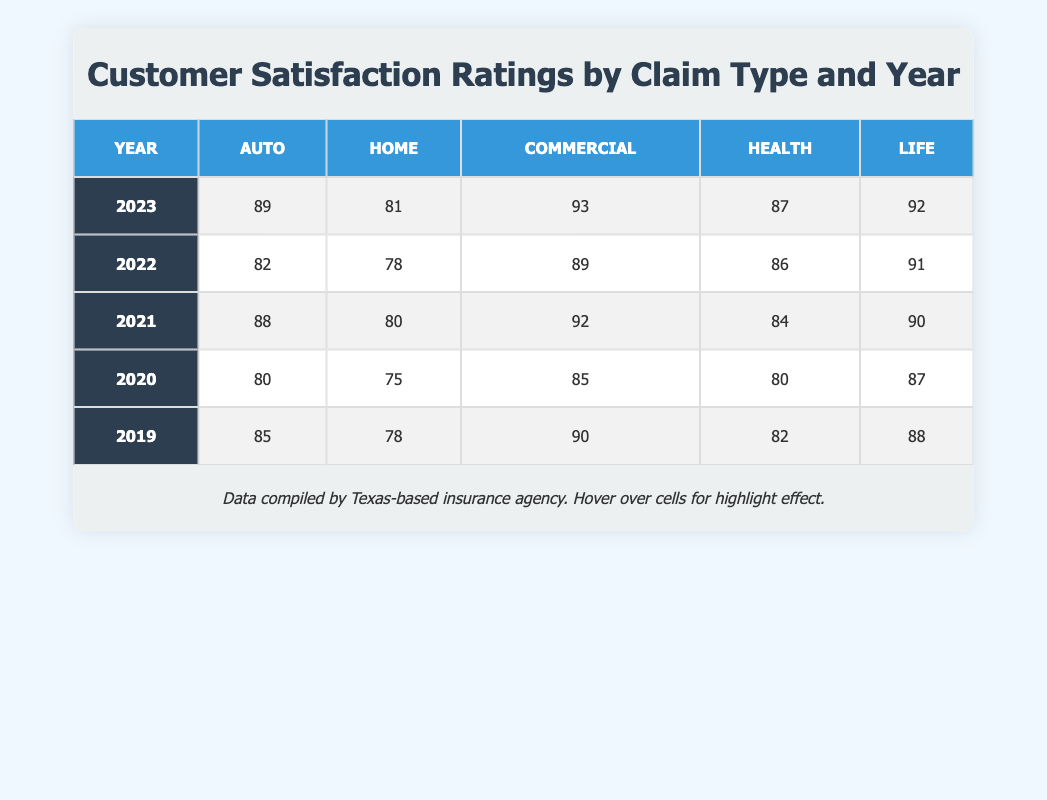What was the customer satisfaction rating for Commercial claims in 2021? The table shows that the rating for Commercial claims in 2021 is indicated in the specific cell corresponding to that year and claim type, which is 92.
Answer: 92 Which claim type had the lowest customer satisfaction rating in 2020? In the year 2020, the ratings for each claim type are as follows: Auto 80, Home 75, Commercial 85, Health 80, Life 87. The Home claim type has the lowest rating at 75.
Answer: Home What is the average customer satisfaction rating for Health claims over the provided years? To find the average for Health claims, we use the ratings from all years: (82 + 80 + 84 + 86 + 87) / 5 = 419 / 5 = 83.8.
Answer: 83.8 Did the customer satisfaction rating for Auto claims improve from 2020 to 2021? The rating for Auto claims in 2020 is 80, while in 2021 it is 88. Since 88 is greater than 80, this indicates that there was an improvement.
Answer: Yes Which year saw the highest customer satisfaction rating for Life claims? By checking the ratings for Life claims across the years, we see they are: 88 (2019), 87 (2020), 90 (2021), 91 (2022), and 92 (2023). The highest rating of 92 occurred in 2023.
Answer: 2023 What is the difference in customer satisfaction ratings for Home claims between 2019 and 2023? The rating for Home claims in 2019 is 78 and in 2023 it is 81. To find the difference, we subtract 78 from 81, resulting in 3.
Answer: 3 Which claim type consistently had the highest ratings across all years listed? By examining the ratings in the table, we see the ratings for each claim type: Commercial has values of 90, 85, 92, 89, and 93, while no other type exceeds these values in any year consistently. Commercial claims had the highest overall ratings.
Answer: Commercial Is it true that all claim types had a higher satisfaction rating in 2023 compared to 2022? The ratings for 2022 and 2023 are compared for each type: Auto (82 vs 89), Home (78 vs 81), Commercial (89 vs 93), Health (86 vs 87), and Life (91 vs 92). Since all comparisons show that 2023 ratings are higher, it is true.
Answer: Yes 